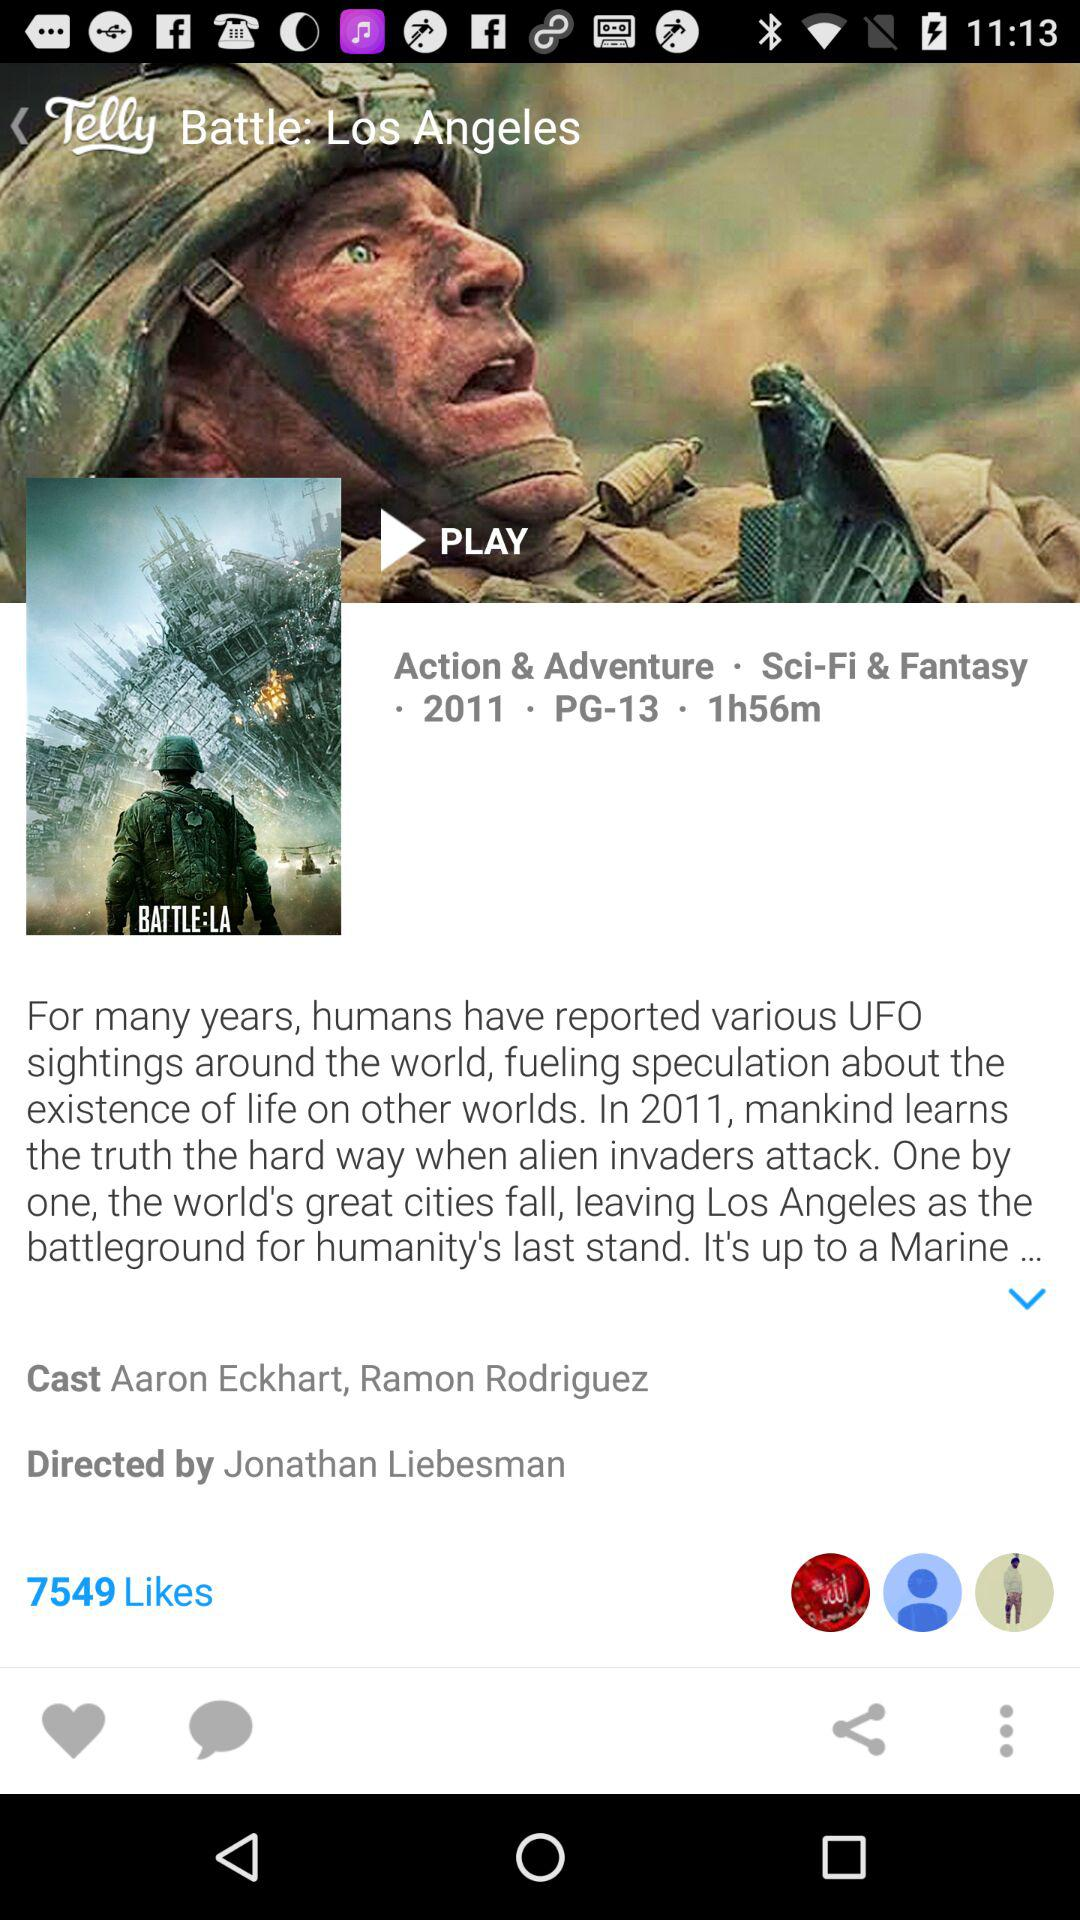What is the title of the movie? The title of the movie is "Battle: Los Angeles". 